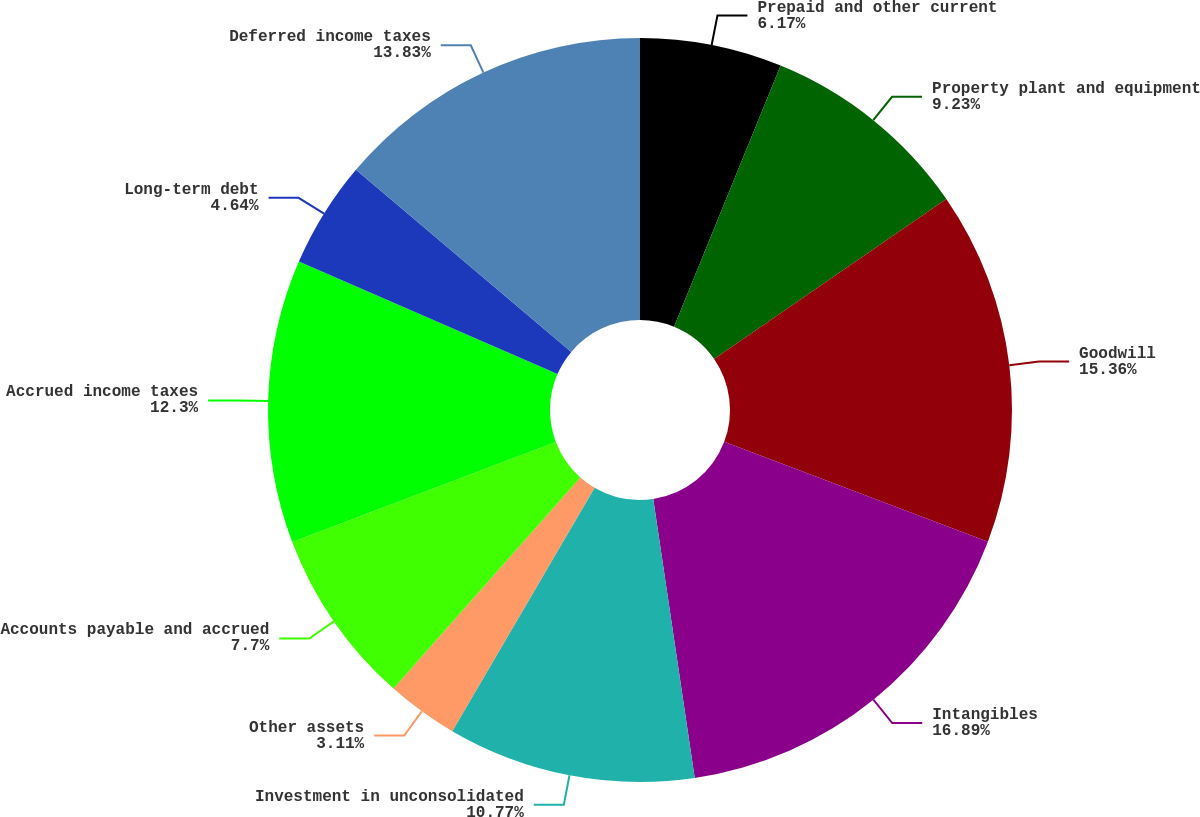Convert chart. <chart><loc_0><loc_0><loc_500><loc_500><pie_chart><fcel>Prepaid and other current<fcel>Property plant and equipment<fcel>Goodwill<fcel>Intangibles<fcel>Investment in unconsolidated<fcel>Other assets<fcel>Accounts payable and accrued<fcel>Accrued income taxes<fcel>Long-term debt<fcel>Deferred income taxes<nl><fcel>6.17%<fcel>9.23%<fcel>15.36%<fcel>16.89%<fcel>10.77%<fcel>3.11%<fcel>7.7%<fcel>12.3%<fcel>4.64%<fcel>13.83%<nl></chart> 